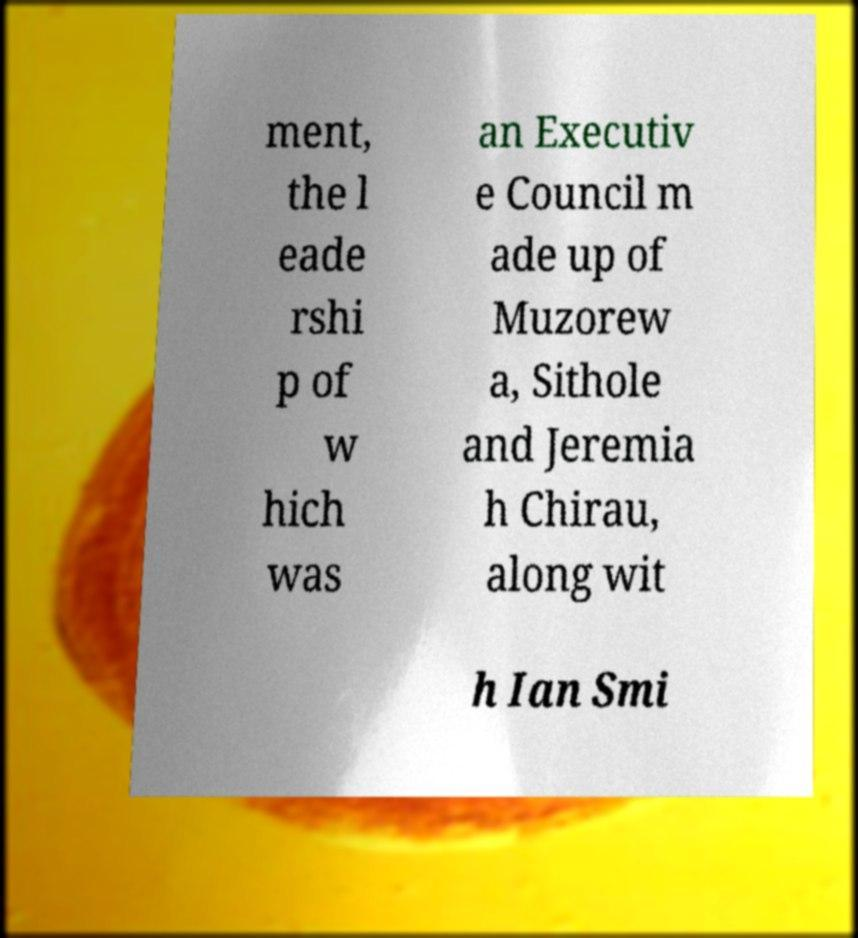I need the written content from this picture converted into text. Can you do that? ment, the l eade rshi p of w hich was an Executiv e Council m ade up of Muzorew a, Sithole and Jeremia h Chirau, along wit h Ian Smi 